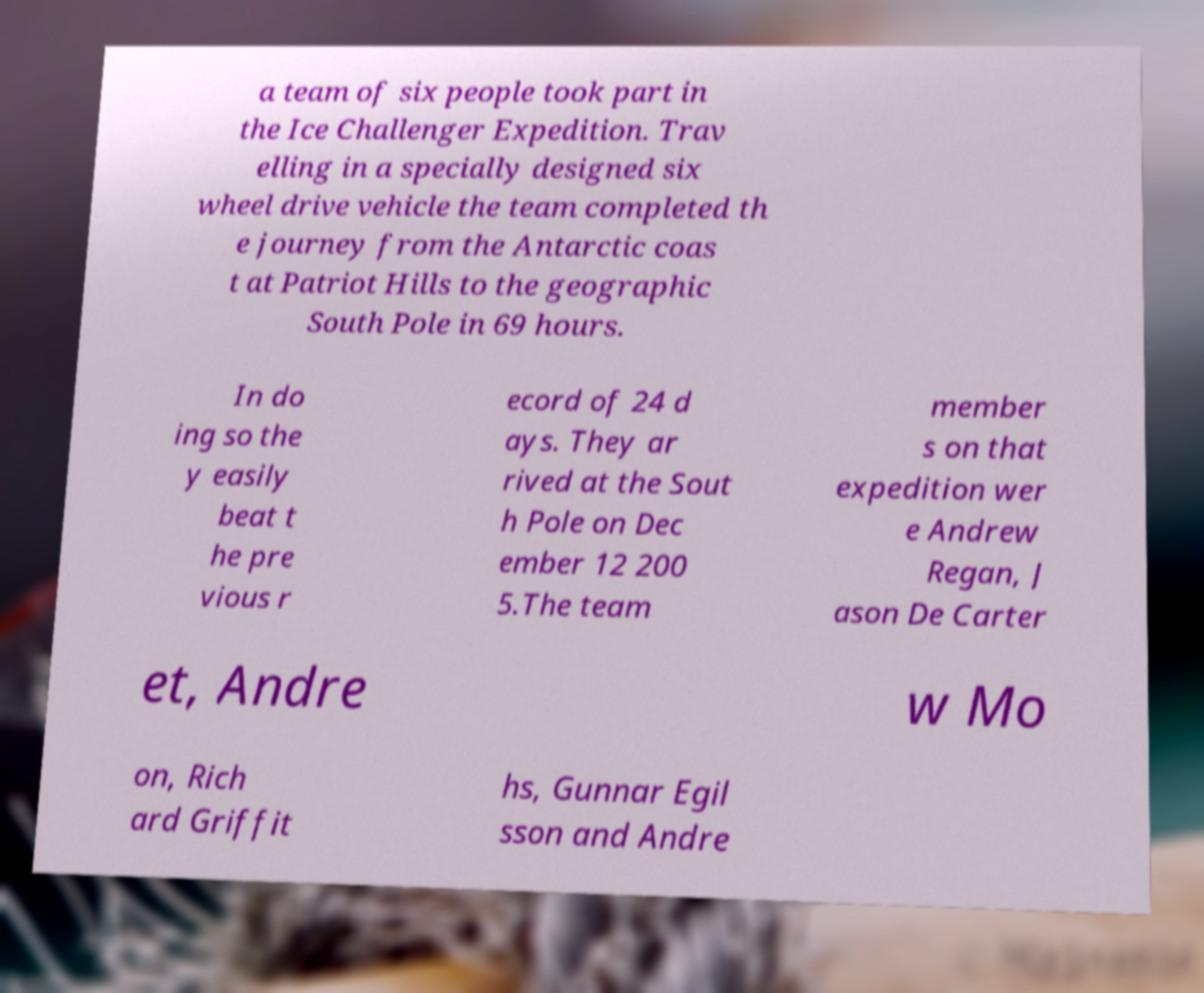For documentation purposes, I need the text within this image transcribed. Could you provide that? a team of six people took part in the Ice Challenger Expedition. Trav elling in a specially designed six wheel drive vehicle the team completed th e journey from the Antarctic coas t at Patriot Hills to the geographic South Pole in 69 hours. In do ing so the y easily beat t he pre vious r ecord of 24 d ays. They ar rived at the Sout h Pole on Dec ember 12 200 5.The team member s on that expedition wer e Andrew Regan, J ason De Carter et, Andre w Mo on, Rich ard Griffit hs, Gunnar Egil sson and Andre 